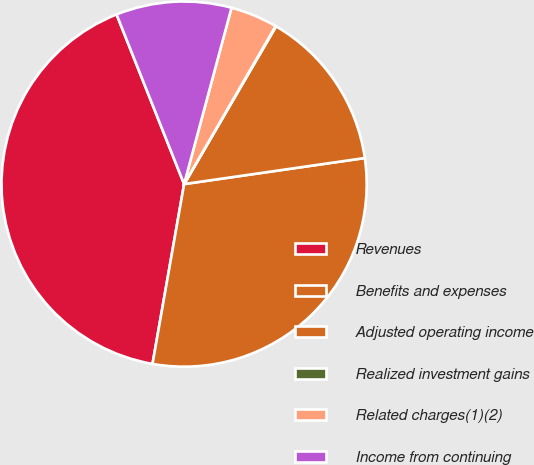Convert chart to OTSL. <chart><loc_0><loc_0><loc_500><loc_500><pie_chart><fcel>Revenues<fcel>Benefits and expenses<fcel>Adjusted operating income<fcel>Realized investment gains<fcel>Related charges(1)(2)<fcel>Income from continuing<nl><fcel>41.2%<fcel>30.05%<fcel>14.32%<fcel>0.05%<fcel>4.17%<fcel>10.21%<nl></chart> 